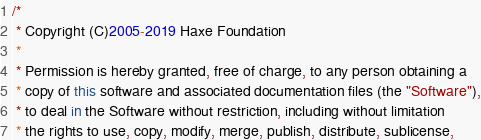<code> <loc_0><loc_0><loc_500><loc_500><_Haxe_>/*
 * Copyright (C)2005-2019 Haxe Foundation
 *
 * Permission is hereby granted, free of charge, to any person obtaining a
 * copy of this software and associated documentation files (the "Software"),
 * to deal in the Software without restriction, including without limitation
 * the rights to use, copy, modify, merge, publish, distribute, sublicense,</code> 